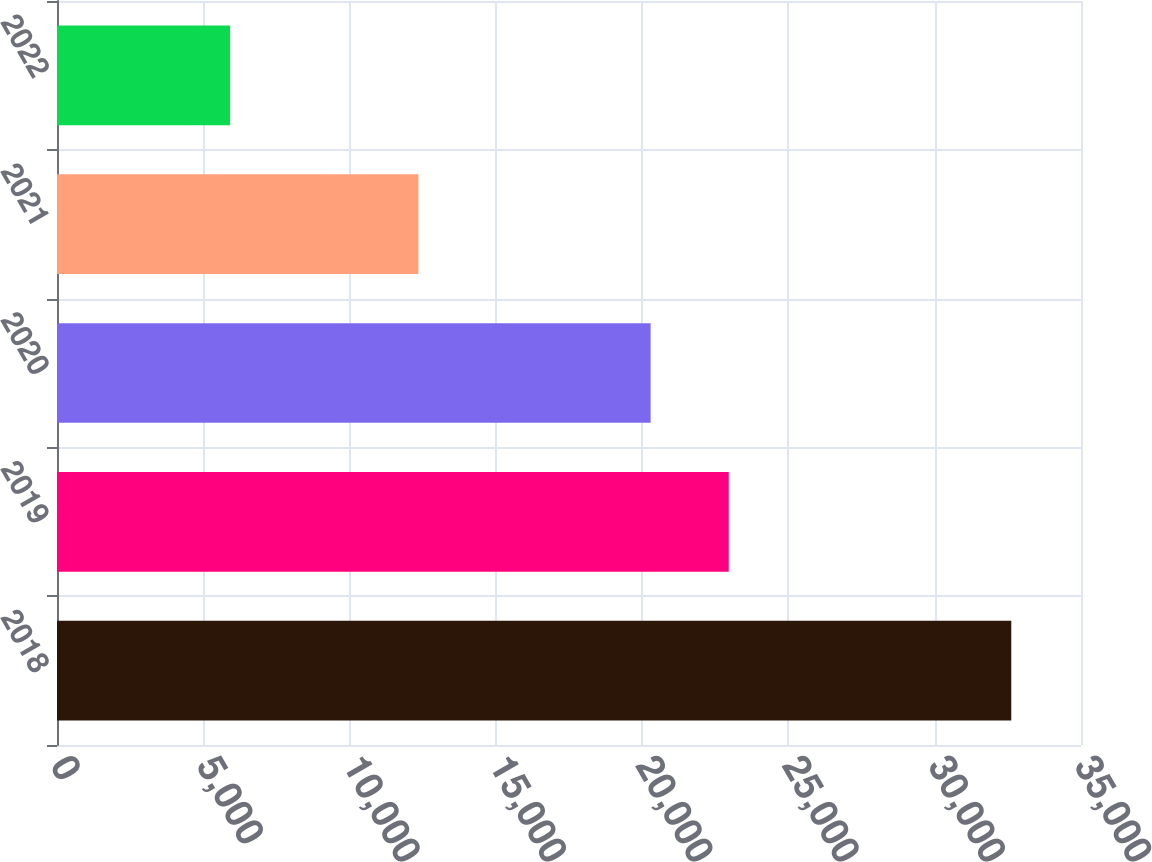<chart> <loc_0><loc_0><loc_500><loc_500><bar_chart><fcel>2018<fcel>2019<fcel>2020<fcel>2021<fcel>2022<nl><fcel>32617<fcel>22959.9<fcel>20290<fcel>12354<fcel>5918<nl></chart> 